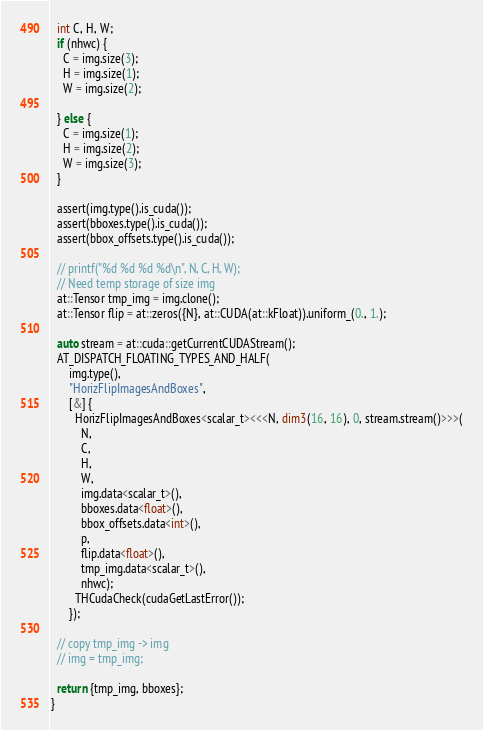Convert code to text. <code><loc_0><loc_0><loc_500><loc_500><_Cuda_>  int C, H, W;
  if (nhwc) {
    C = img.size(3);
    H = img.size(1);
    W = img.size(2);

  } else {
    C = img.size(1);
    H = img.size(2);
    W = img.size(3);
  }

  assert(img.type().is_cuda());
  assert(bboxes.type().is_cuda());
  assert(bbox_offsets.type().is_cuda());

  // printf("%d %d %d %d\n", N, C, H, W);
  // Need temp storage of size img
  at::Tensor tmp_img = img.clone();
  at::Tensor flip = at::zeros({N}, at::CUDA(at::kFloat)).uniform_(0., 1.);

  auto stream = at::cuda::getCurrentCUDAStream();
  AT_DISPATCH_FLOATING_TYPES_AND_HALF(
      img.type(),
      "HorizFlipImagesAndBoxes",
      [&] {
        HorizFlipImagesAndBoxes<scalar_t><<<N, dim3(16, 16), 0, stream.stream()>>>(
          N,
          C,
          H,
          W,
          img.data<scalar_t>(),
          bboxes.data<float>(),
          bbox_offsets.data<int>(),
          p,
          flip.data<float>(),
          tmp_img.data<scalar_t>(),
          nhwc);
        THCudaCheck(cudaGetLastError());
      });

  // copy tmp_img -> img
  // img = tmp_img;

  return {tmp_img, bboxes};
}

</code> 